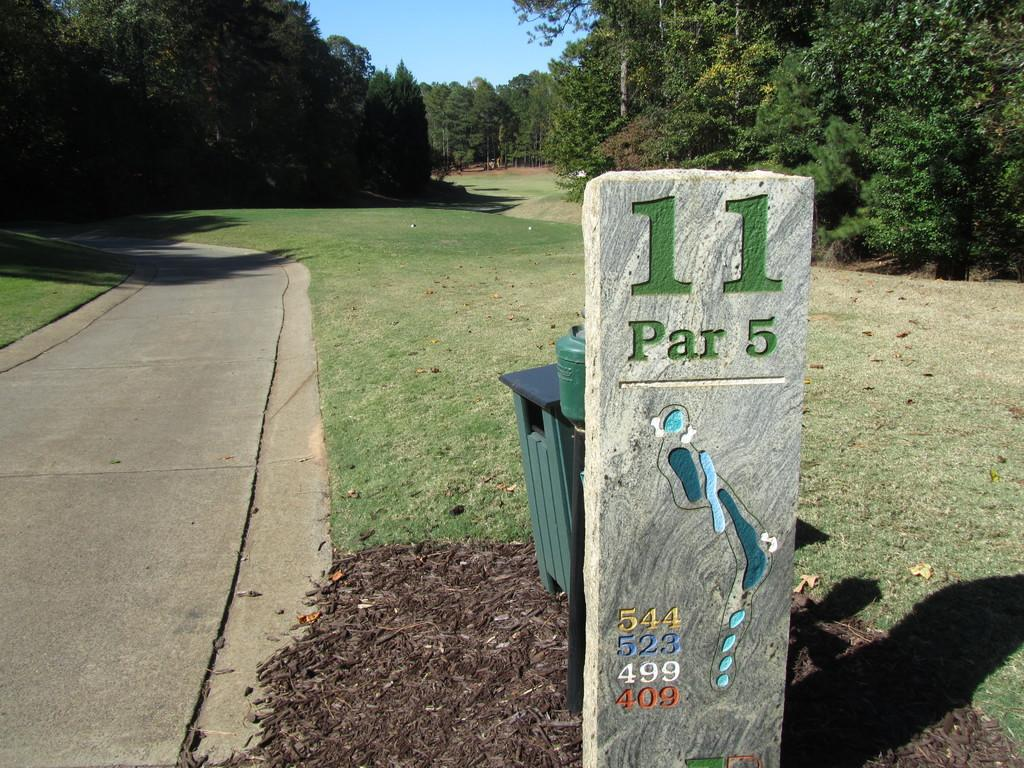<image>
Offer a succinct explanation of the picture presented. A golf course sign shows hole #11 to be a par 5. 